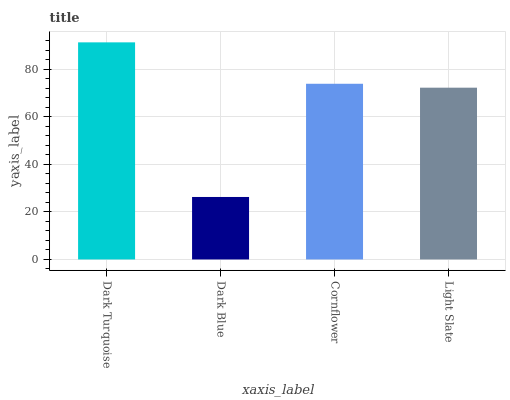Is Dark Blue the minimum?
Answer yes or no. Yes. Is Dark Turquoise the maximum?
Answer yes or no. Yes. Is Cornflower the minimum?
Answer yes or no. No. Is Cornflower the maximum?
Answer yes or no. No. Is Cornflower greater than Dark Blue?
Answer yes or no. Yes. Is Dark Blue less than Cornflower?
Answer yes or no. Yes. Is Dark Blue greater than Cornflower?
Answer yes or no. No. Is Cornflower less than Dark Blue?
Answer yes or no. No. Is Cornflower the high median?
Answer yes or no. Yes. Is Light Slate the low median?
Answer yes or no. Yes. Is Dark Turquoise the high median?
Answer yes or no. No. Is Dark Blue the low median?
Answer yes or no. No. 